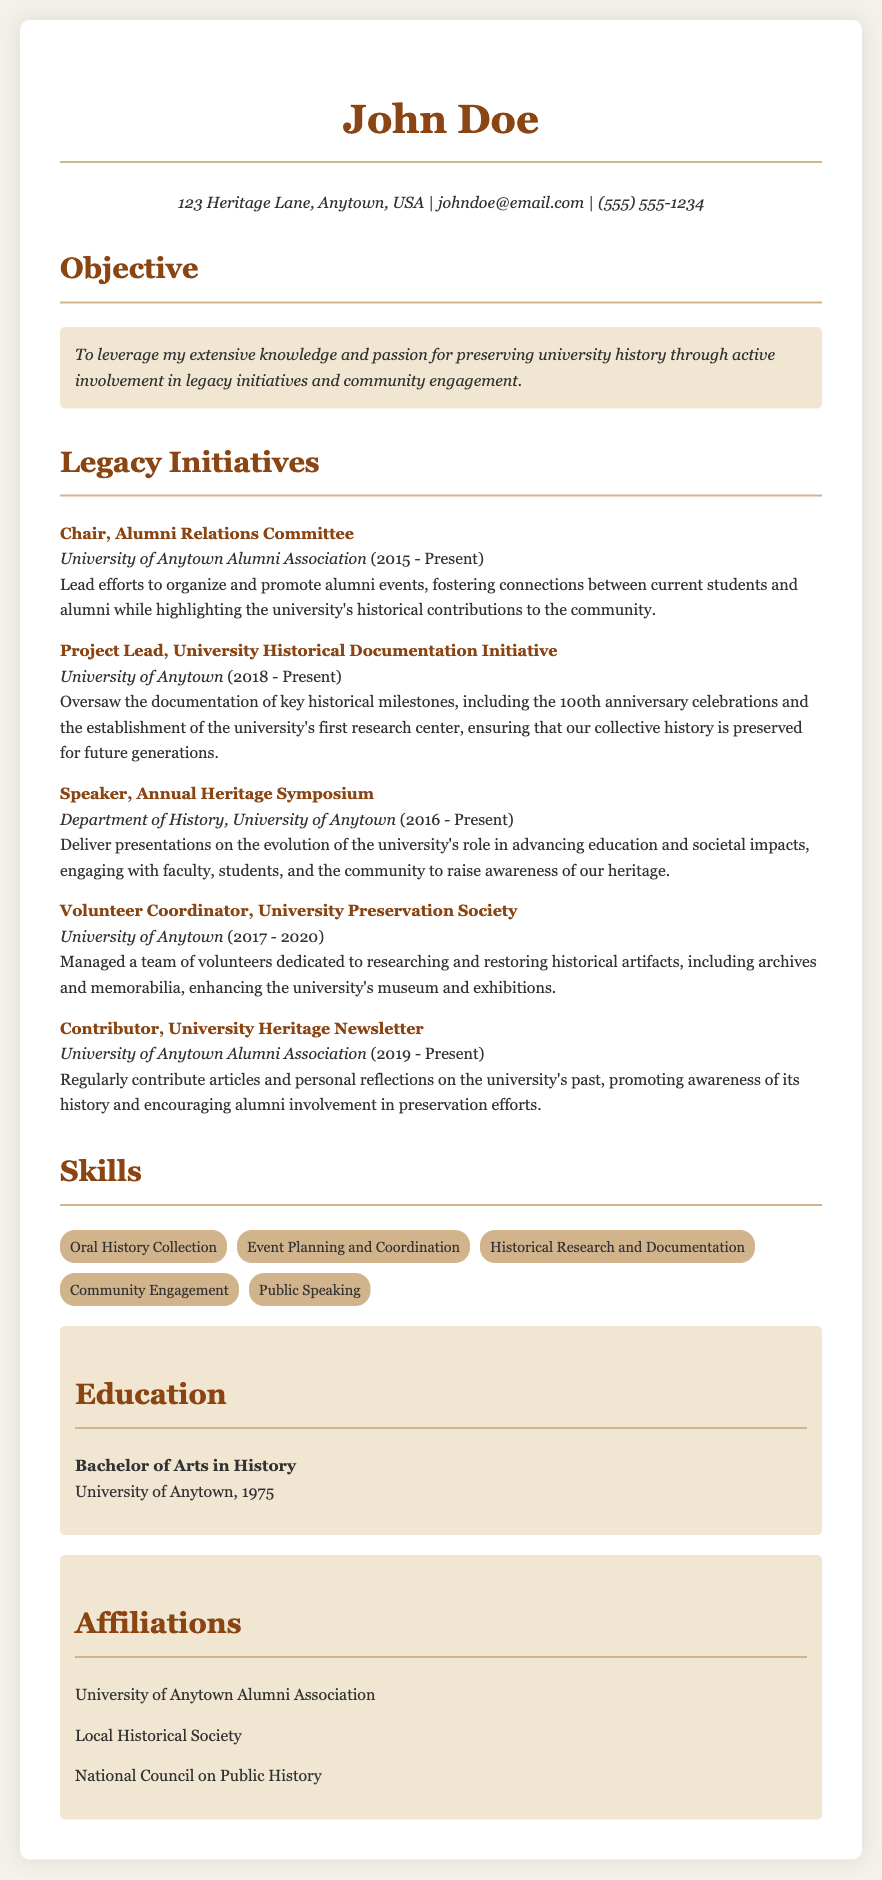What is the name of the individual in the CV? The name is clearly stated at the top of the document under the title.
Answer: John Doe What position does John Doe hold in the Alumni Relations Committee? The position is described in the section detailing his legacy initiatives.
Answer: Chair In what year did John Doe begin his role in the University Historical Documentation Initiative? The starting year is mentioned next to the initiative's title in the document.
Answer: 2018 Which organization's newsletter does John Doe contribute to? The organization is specified in the legacy initiatives section.
Answer: University of Anytown Alumni Association How many years has John Doe been a speaker at the Annual Heritage Symposium? The years are deduced from the starting date to the current year mentioned in the document.
Answer: 7 years What is one of the main focuses of the presentations John Doe delivers? The focus is indicated in the description of his role within the symposium in the legacy initiatives.
Answer: Evolution of the university's role What educational qualification does John Doe have? The qualification is provided in the education section of the CV.
Answer: Bachelor of Arts in History How many affiliations does John Doe list in the CV? The number of affiliations can be counted from the list presented in the affiliations section.
Answer: 3 